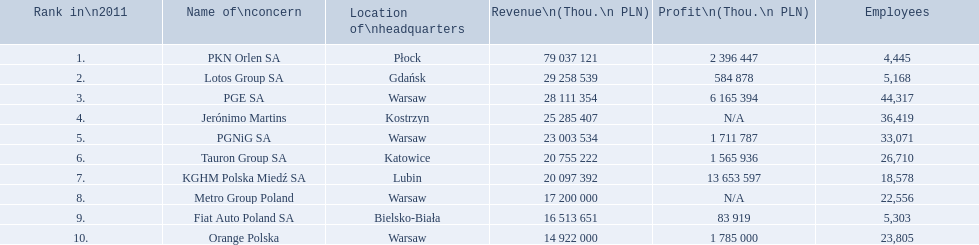Which organization has its headquarters in warsaw? PGE SA, PGNiG SA, Metro Group Poland. Which of them had a profitable year? PGE SA, PGNiG SA. Among these, how many people are employed at the organization with the lowest profit? 33,071. 